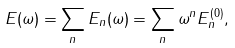Convert formula to latex. <formula><loc_0><loc_0><loc_500><loc_500>E ( \omega ) = \sum _ { n } E _ { n } ( \omega ) = \sum _ { n } \omega ^ { n } E _ { n } ^ { ( 0 ) } ,</formula> 